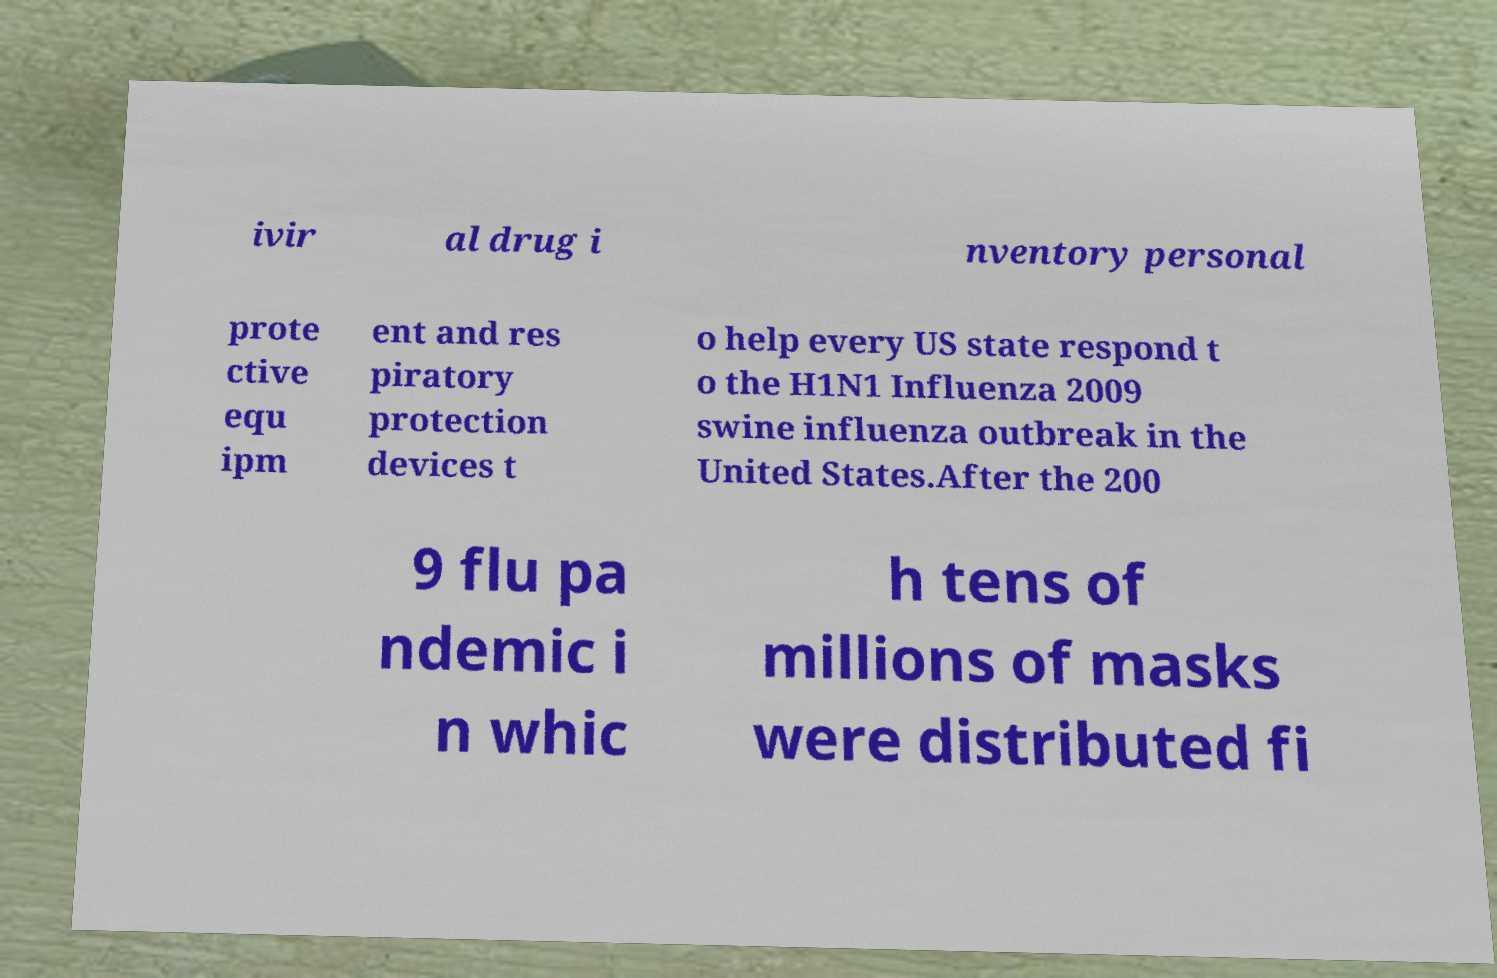For documentation purposes, I need the text within this image transcribed. Could you provide that? ivir al drug i nventory personal prote ctive equ ipm ent and res piratory protection devices t o help every US state respond t o the H1N1 Influenza 2009 swine influenza outbreak in the United States.After the 200 9 flu pa ndemic i n whic h tens of millions of masks were distributed fi 